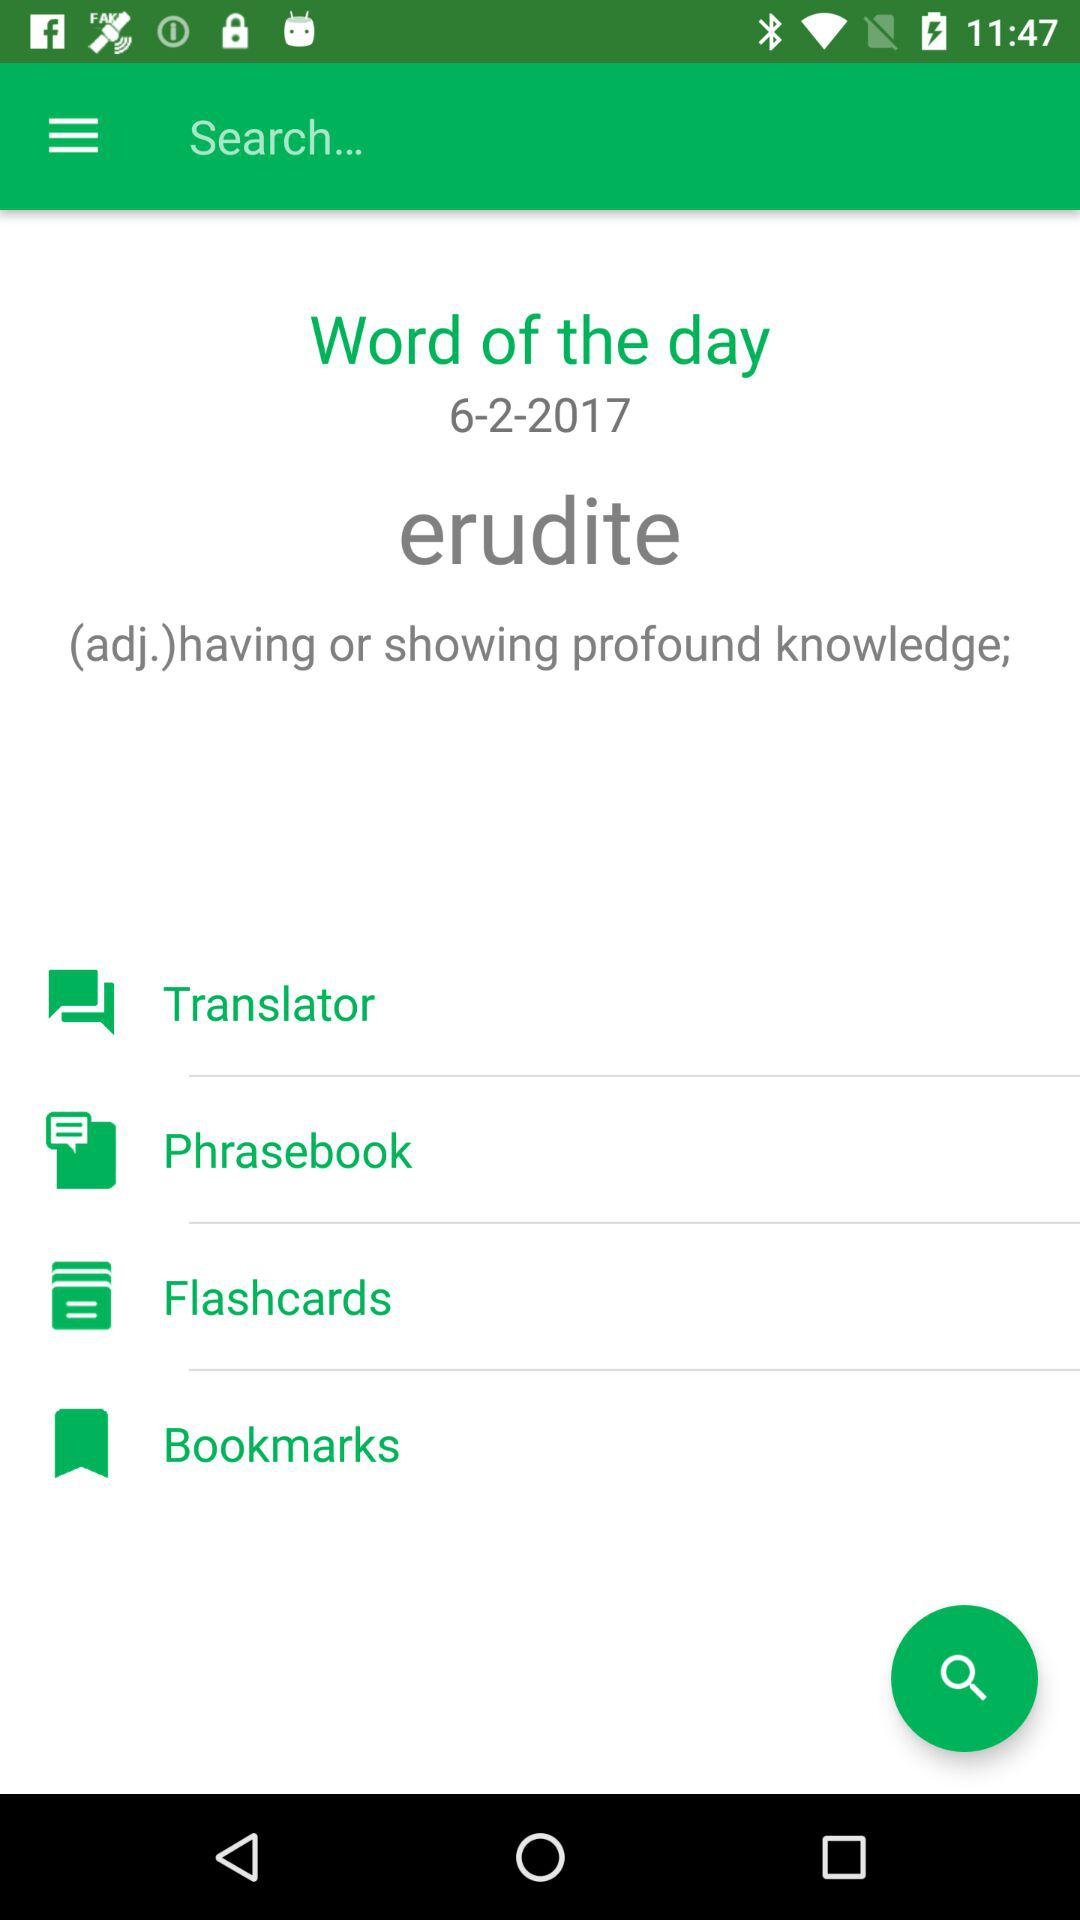What is the mentioned date? The mentioned date is June 2, 2017. 